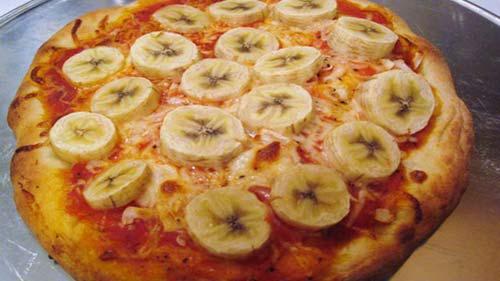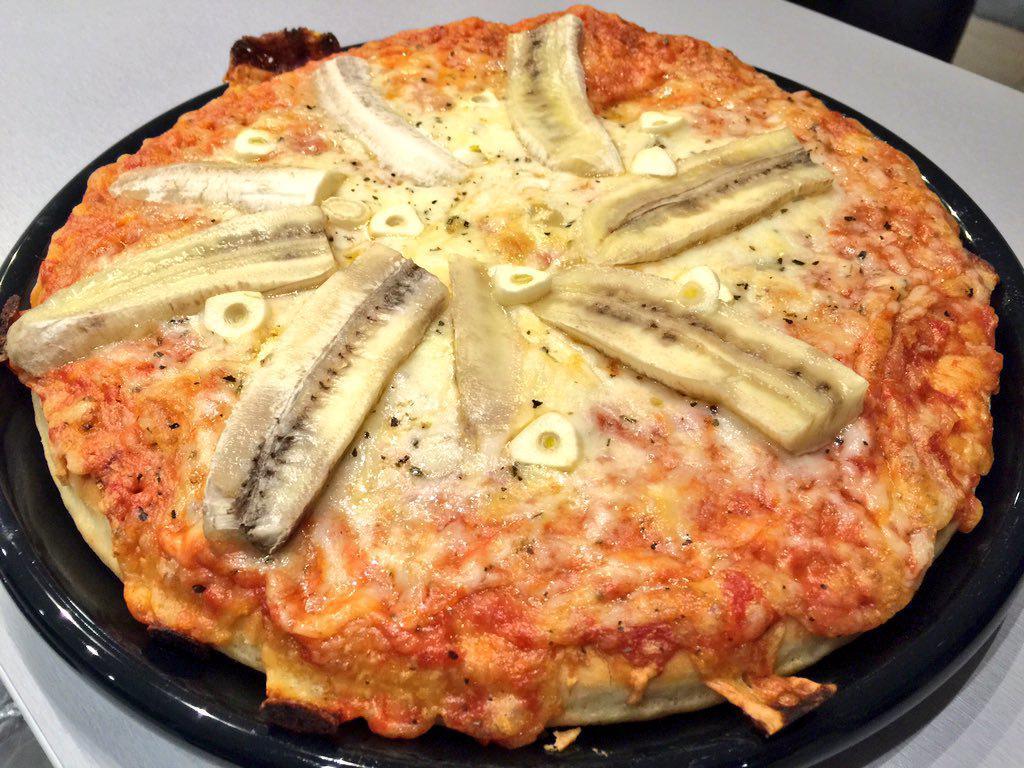The first image is the image on the left, the second image is the image on the right. Considering the images on both sides, is "One image shows a pizza served on a white platter." valid? Answer yes or no. No. 